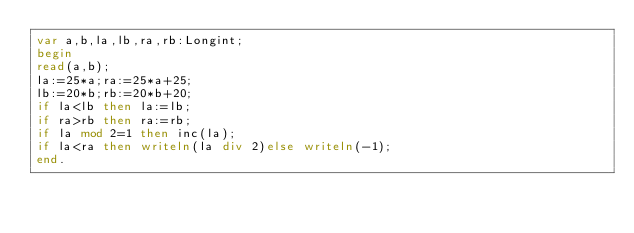<code> <loc_0><loc_0><loc_500><loc_500><_Pascal_>var a,b,la,lb,ra,rb:Longint;
begin
read(a,b);
la:=25*a;ra:=25*a+25;
lb:=20*b;rb:=20*b+20;
if la<lb then la:=lb;
if ra>rb then ra:=rb;
if la mod 2=1 then inc(la);
if la<ra then writeln(la div 2)else writeln(-1);
end.
</code> 